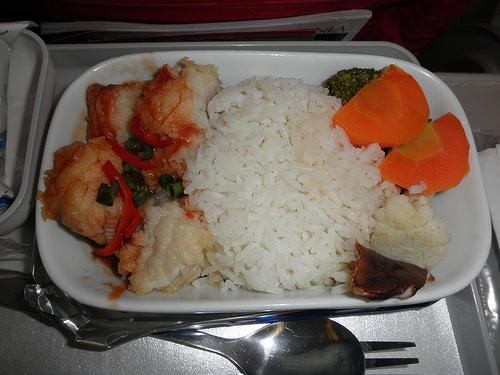Question: what is in the center of the plate?
Choices:
A. Chicken.
B. Fish.
C. Rice.
D. Salmon.
Answer with the letter. Answer: C Question: what type of vegetable is on top of the broccoli?
Choices:
A. Carrots.
B. Potatoes.
C. Celery.
D. Cabbage.
Answer with the letter. Answer: A Question: how many spoons are there?
Choices:
A. Three.
B. Four.
C. One.
D. Five.
Answer with the letter. Answer: C Question: where is the Broccoli?
Choices:
A. Under Carrots.
B. On the side of the plate.
C. On the serving plate.
D. Beside the potatoes.
Answer with the letter. Answer: A Question: how many pieces of meat are there?
Choices:
A. 4.
B. 1.
C. 2.
D. 3.
Answer with the letter. Answer: A Question: what color are the utensils?
Choices:
A. White.
B. Black.
C. Silver.
D. Gold.
Answer with the letter. Answer: C Question: how many carrots are there?
Choices:
A. Three.
B. Four.
C. Two.
D. Five.
Answer with the letter. Answer: C 